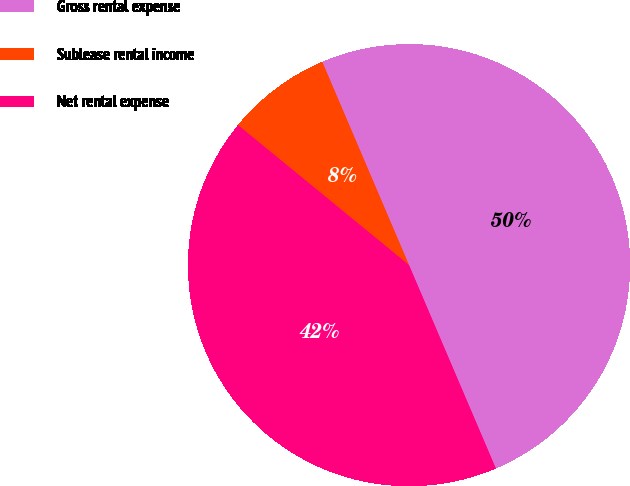<chart> <loc_0><loc_0><loc_500><loc_500><pie_chart><fcel>Gross rental expense<fcel>Sublease rental income<fcel>Net rental expense<nl><fcel>50.0%<fcel>7.66%<fcel>42.34%<nl></chart> 